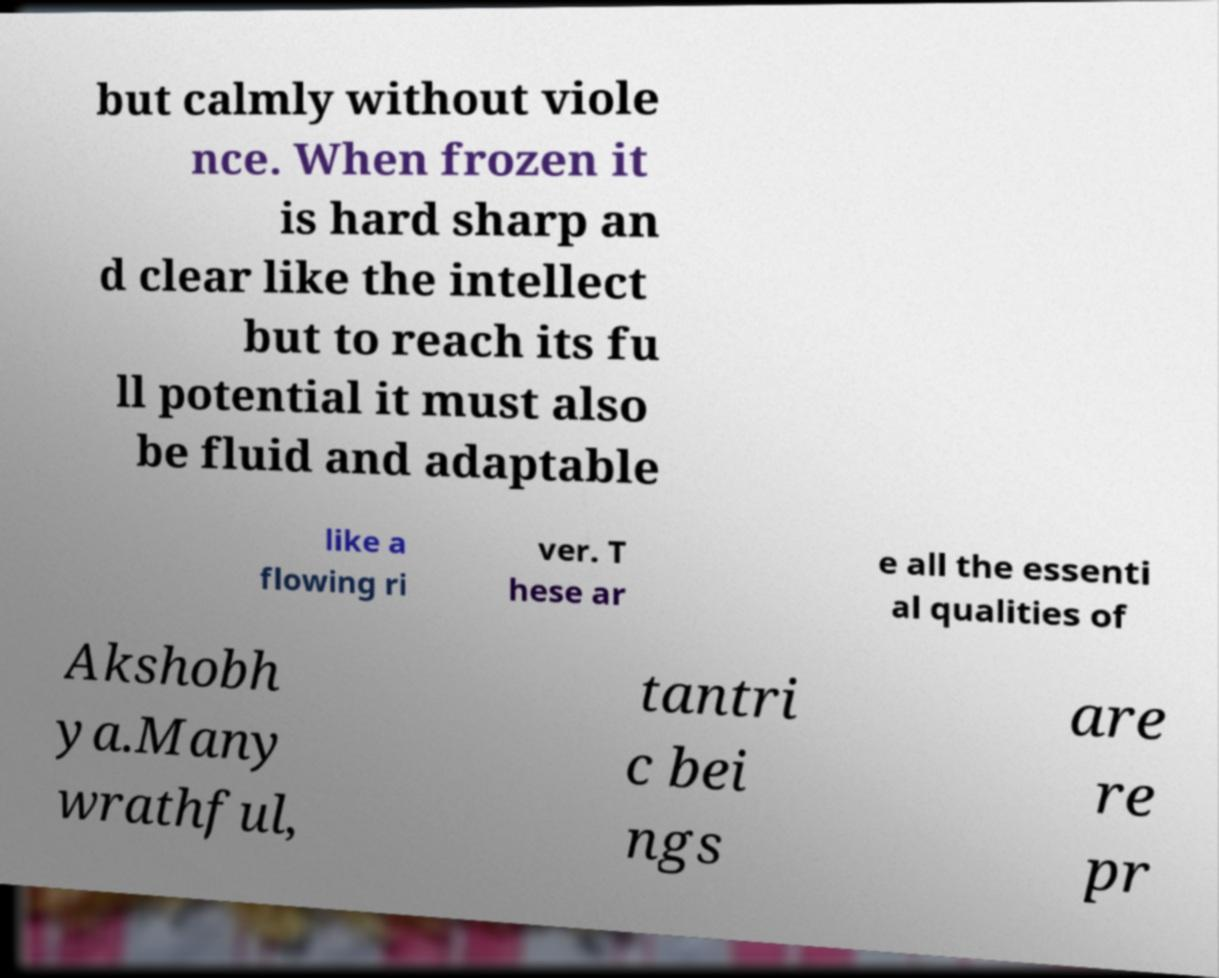Please read and relay the text visible in this image. What does it say? but calmly without viole nce. When frozen it is hard sharp an d clear like the intellect but to reach its fu ll potential it must also be fluid and adaptable like a flowing ri ver. T hese ar e all the essenti al qualities of Akshobh ya.Many wrathful, tantri c bei ngs are re pr 